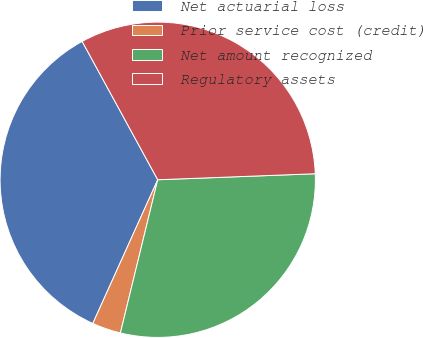Convert chart. <chart><loc_0><loc_0><loc_500><loc_500><pie_chart><fcel>Net actuarial loss<fcel>Prior service cost (credit)<fcel>Net amount recognized<fcel>Regulatory assets<nl><fcel>35.29%<fcel>2.95%<fcel>29.41%<fcel>32.35%<nl></chart> 